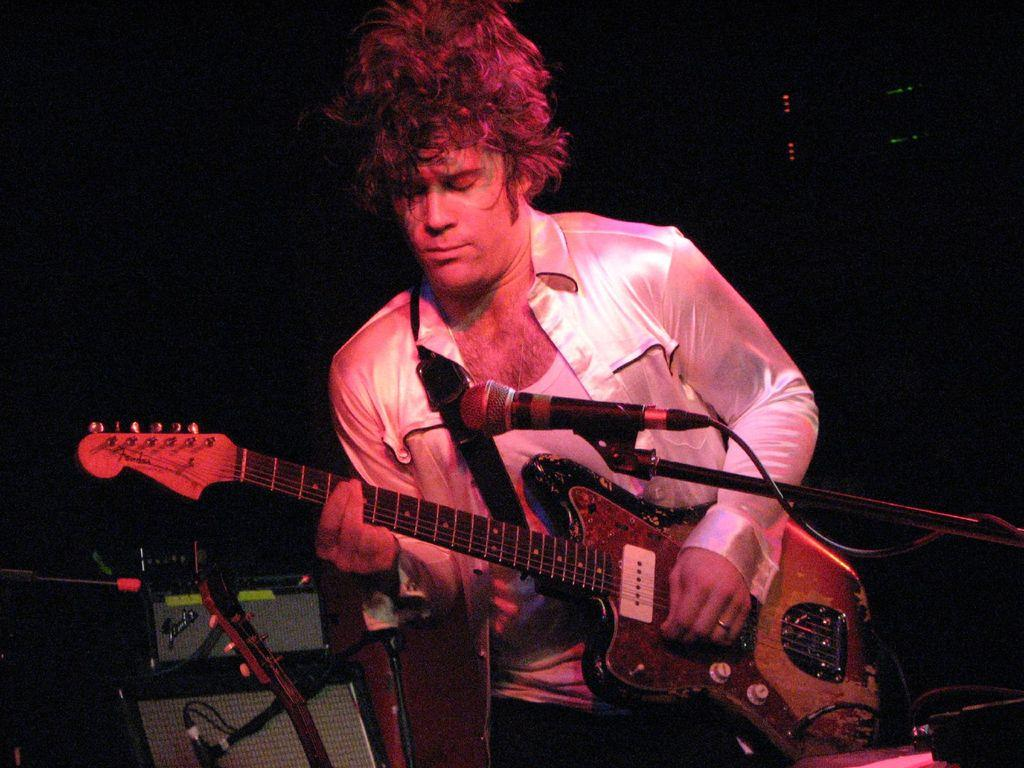Who is the main subject in the image? There is a man in the image. What is the man holding in his hand? The man is holding a guitar in his hand. What object is in front of the man? There is a microphone (mic) in front of the man. What type of skin condition does the man have in the image? There is no information about the man's skin condition in the image, so it cannot be determined. 